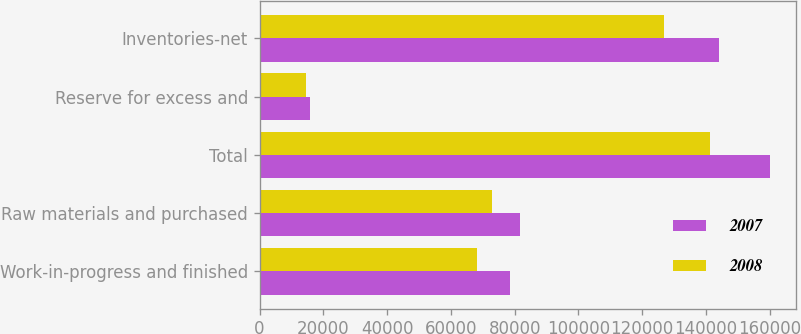Convert chart to OTSL. <chart><loc_0><loc_0><loc_500><loc_500><stacked_bar_chart><ecel><fcel>Work-in-progress and finished<fcel>Raw materials and purchased<fcel>Total<fcel>Reserve for excess and<fcel>Inventories-net<nl><fcel>2007<fcel>78467<fcel>81750<fcel>160217<fcel>15862<fcel>144114<nl><fcel>2008<fcel>68287<fcel>72943<fcel>141230<fcel>14467<fcel>126763<nl></chart> 